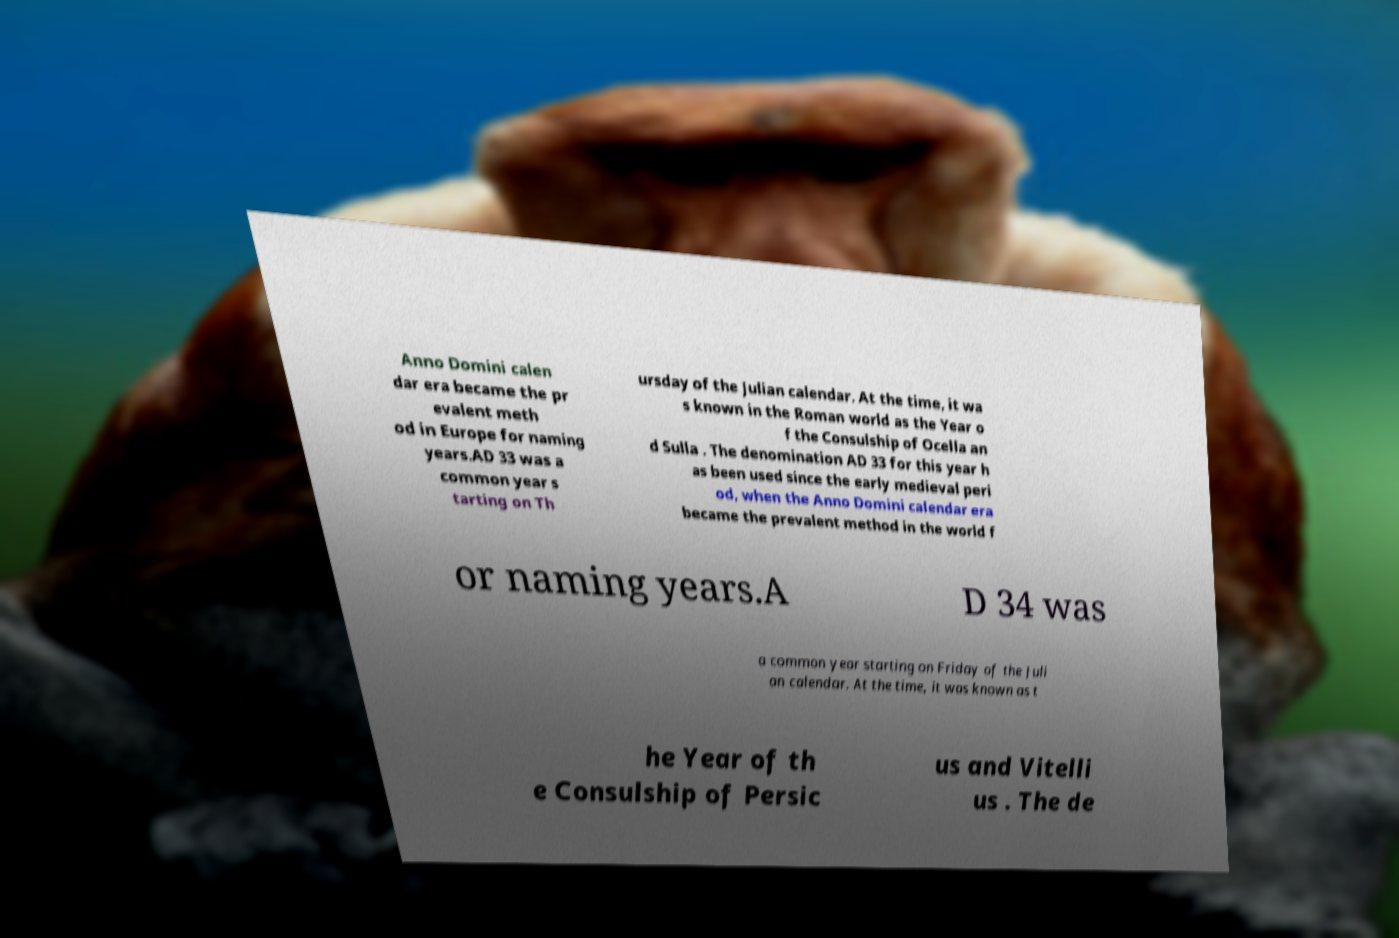Can you accurately transcribe the text from the provided image for me? Anno Domini calen dar era became the pr evalent meth od in Europe for naming years.AD 33 was a common year s tarting on Th ursday of the Julian calendar. At the time, it wa s known in the Roman world as the Year o f the Consulship of Ocella an d Sulla . The denomination AD 33 for this year h as been used since the early medieval peri od, when the Anno Domini calendar era became the prevalent method in the world f or naming years.A D 34 was a common year starting on Friday of the Juli an calendar. At the time, it was known as t he Year of th e Consulship of Persic us and Vitelli us . The de 